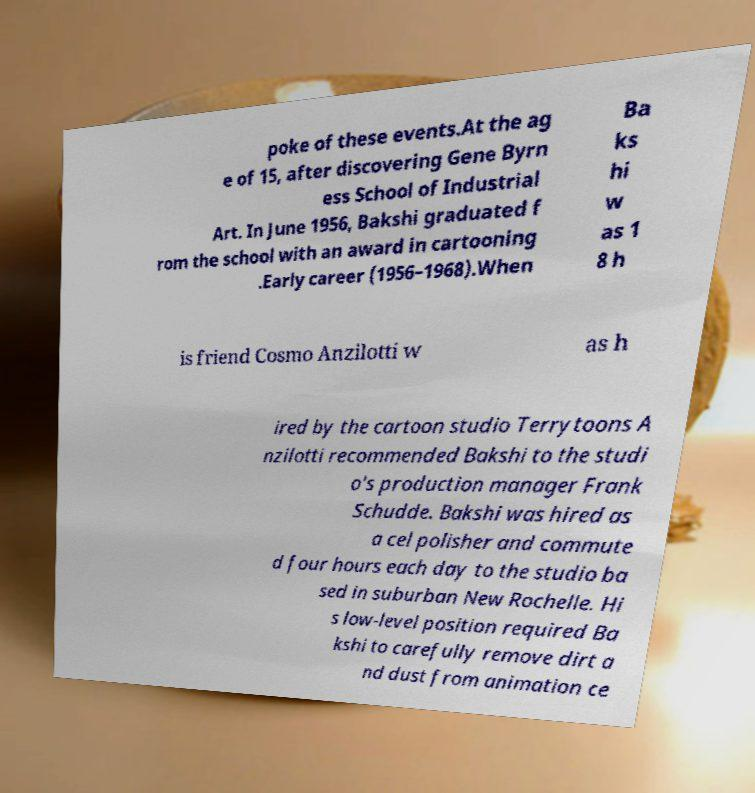For documentation purposes, I need the text within this image transcribed. Could you provide that? poke of these events.At the ag e of 15, after discovering Gene Byrn ess School of Industrial Art. In June 1956, Bakshi graduated f rom the school with an award in cartooning .Early career (1956–1968).When Ba ks hi w as 1 8 h is friend Cosmo Anzilotti w as h ired by the cartoon studio Terrytoons A nzilotti recommended Bakshi to the studi o's production manager Frank Schudde. Bakshi was hired as a cel polisher and commute d four hours each day to the studio ba sed in suburban New Rochelle. Hi s low-level position required Ba kshi to carefully remove dirt a nd dust from animation ce 